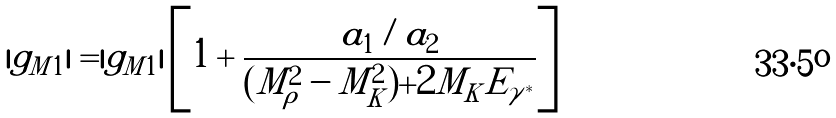<formula> <loc_0><loc_0><loc_500><loc_500>| g _ { M 1 } | = | \tilde { g } _ { M 1 } | \left [ 1 + \frac { a _ { 1 } / a _ { 2 } } { ( M ^ { 2 } _ { \rho } - M ^ { 2 } _ { K } ) + 2 M _ { K } E _ { \gamma ^ { * } } } \right ]</formula> 